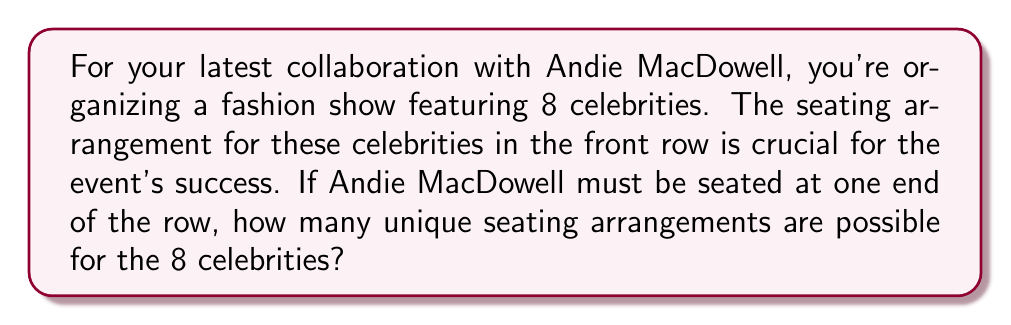Solve this math problem. Let's approach this step-by-step:

1) First, we need to recognize that this is a permutation problem. We're arranging 8 celebrities in a specific order.

2) Andie MacDowell must be seated at one end of the row. This means we have 2 choices for her position: either the far left or the far right.

3) Once Andie's position is fixed, we need to arrange the remaining 7 celebrities.

4) The number of ways to arrange 7 people in a line is a straightforward permutation: $P(7,7) = 7!$

5) For each of Andie's 2 possible positions, we have 7! arrangements of the other celebrities.

6) Therefore, the total number of unique seating arrangements is:

   $$2 \times 7! = 2 \times 5040 = 10080$$

This can also be written as:

$$2 \times P(7,7) = 2 \times 7! = 2 \times (7 \times 6 \times 5 \times 4 \times 3 \times 2 \times 1) = 10080$$
Answer: 10080 unique seating arrangements 